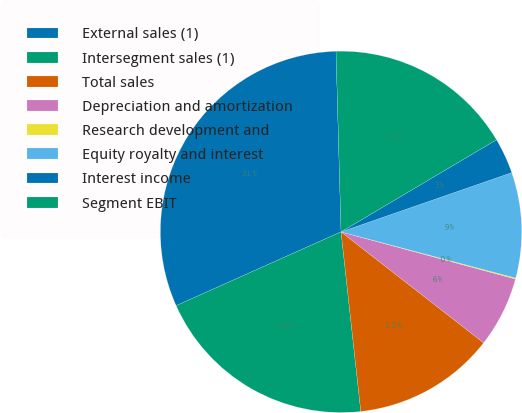Convert chart to OTSL. <chart><loc_0><loc_0><loc_500><loc_500><pie_chart><fcel>External sales (1)<fcel>Intersegment sales (1)<fcel>Total sales<fcel>Depreciation and amortization<fcel>Research development and<fcel>Equity royalty and interest<fcel>Interest income<fcel>Segment EBIT<nl><fcel>31.25%<fcel>20.05%<fcel>12.73%<fcel>6.32%<fcel>0.09%<fcel>9.43%<fcel>3.2%<fcel>16.93%<nl></chart> 